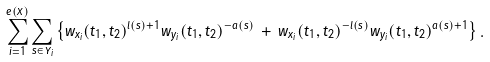<formula> <loc_0><loc_0><loc_500><loc_500>\sum _ { i = 1 } ^ { e ( X ) } \sum _ { s \in Y _ { i } } \left \{ w _ { x _ { i } } ( t _ { 1 } , t _ { 2 } ) ^ { l ( s ) + 1 } w _ { y _ { i } } ( t _ { 1 } , t _ { 2 } ) ^ { - a ( s ) } \, + \, w _ { x _ { i } } ( t _ { 1 } , t _ { 2 } ) ^ { - l ( s ) } w _ { y _ { i } } ( t _ { 1 } , t _ { 2 } ) ^ { a ( s ) + 1 } \right \} .</formula> 